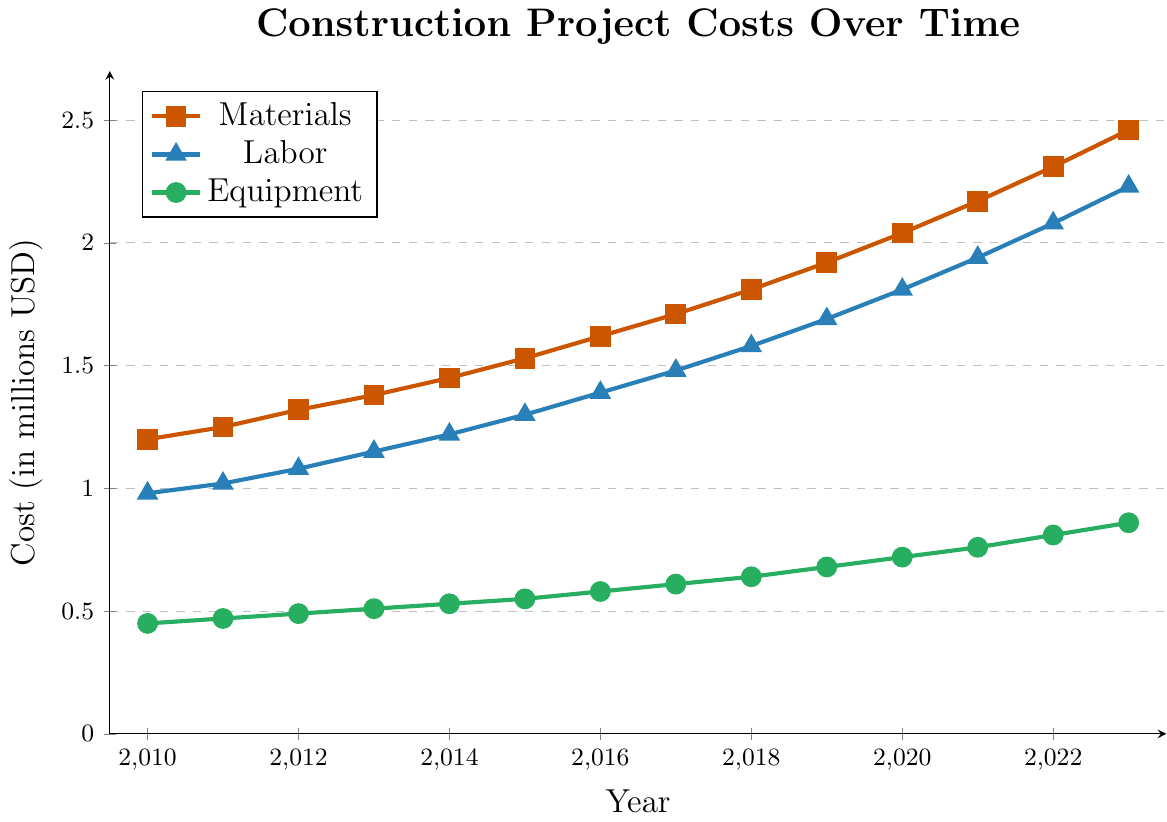What was the cost of materials in 2020 compared to labor and equipment in the same year? Checking the vertical alignment of the data points for all three variables (materials, labor, equipment) at the year 2020, the cost of materials was 2.04 million USD, labor was 1.81 million USD, and equipment was 0.72 million USD.
Answer: Materials: 2.04, Labor: 1.81, Equipment: 0.72 What is the overall trend in the cost of materials from 2010 to 2023? Observing the line for materials (colored in orange), there's a consistent upward trend from 1.2 million USD in 2010 to 2.46 million USD in 2023.
Answer: Increasing Which category showed the highest percentage increase from 2010 to 2023? First calculate the percentage increase for each category. For materials: ((2.46 - 1.2) / 1.2) * 100 ≈ 105%. For labor: ((2.23 - 0.98) / 0.98) * 100 ≈ 127%. For equipment: ((0.86 - 0.45) / 0.45) * 100 ≈ 91%. Labor had the highest percentage increase with approximately 127%.
Answer: Labor Which year did labor costs surpass equipment costs by more than one million USD? Examining the plotted lines, we need to find the first year where the vertical distance between labor (blue) and equipment (green) lines exceeds 1 million USD. This condition is first met in 2019, where labor is at 1.69 and equipment at 0.68. The difference is 1.01 million USD.
Answer: 2019 What was the total cost of all three categories combined in 2011? The sum of the costs for materials, labor, and equipment in 2011 is 1.25 + 1.02 + 0.47 = 2.74 million USD.
Answer: 2.74 How did the cost of equipment change from 2015 to 2020? The cost was at 0.55 million USD in 2015 and rose to 0.72 million USD in 2020. The change is 0.72 - 0.55 = 0.17 million USD.
Answer: Increased by 0.17 When was the smallest gap between the costs of materials and labor? Examining the lines for materials and labor, the smallest vertical gap occurs in 2010 with materials at 1.2 and labor at 0.98. The gap is 0.22 million USD.
Answer: 2010 How much did the cost of labor increase from 2013 to 2023? Labor cost in 2013 was 1.15 million USD and in 2023 it was 2.23 million USD. The increase is 2.23 - 1.15 = 1.08 million USD.
Answer: 1.08 What year did the cost for materials first exceed 2 million USD? The materials cost first exceeded 2 million USD in 2020, reaching 2.04 million USD.
Answer: 2020 